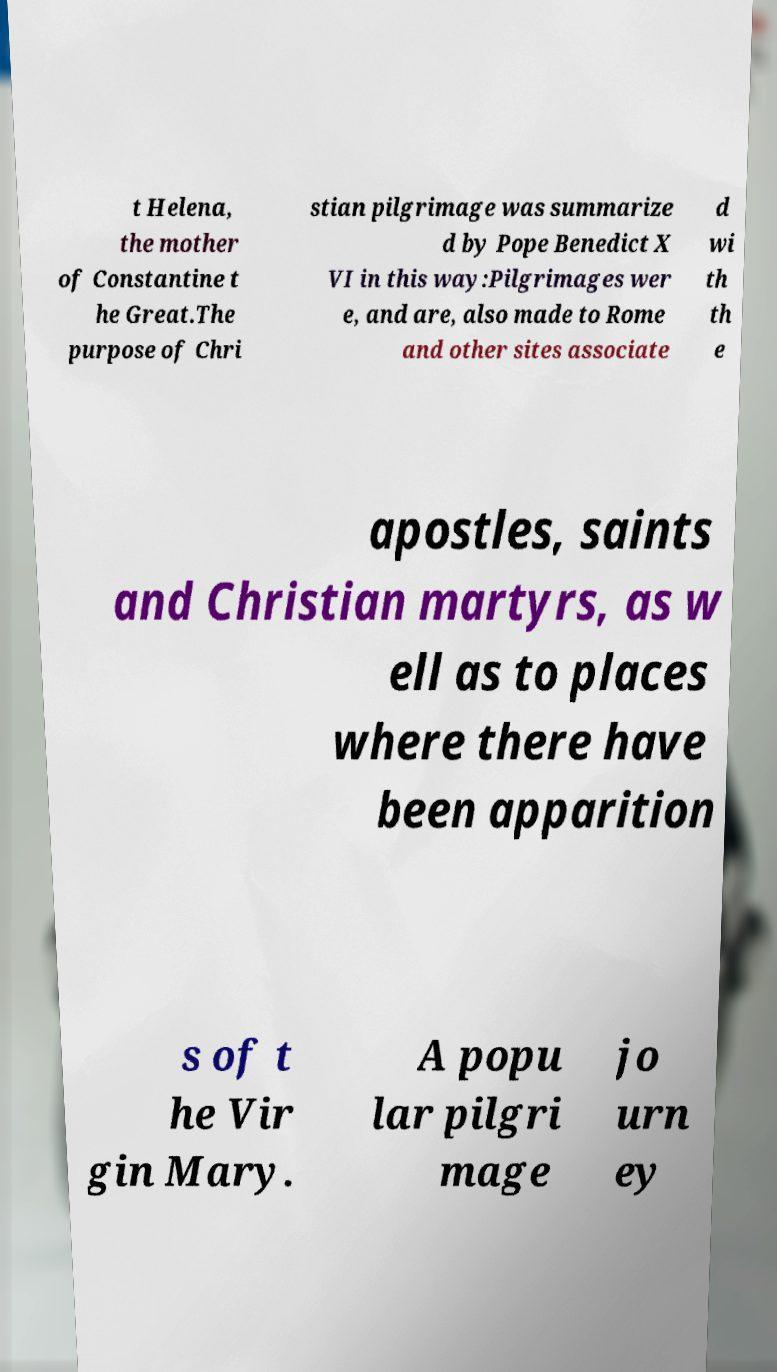Could you extract and type out the text from this image? t Helena, the mother of Constantine t he Great.The purpose of Chri stian pilgrimage was summarize d by Pope Benedict X VI in this way:Pilgrimages wer e, and are, also made to Rome and other sites associate d wi th th e apostles, saints and Christian martyrs, as w ell as to places where there have been apparition s of t he Vir gin Mary. A popu lar pilgri mage jo urn ey 